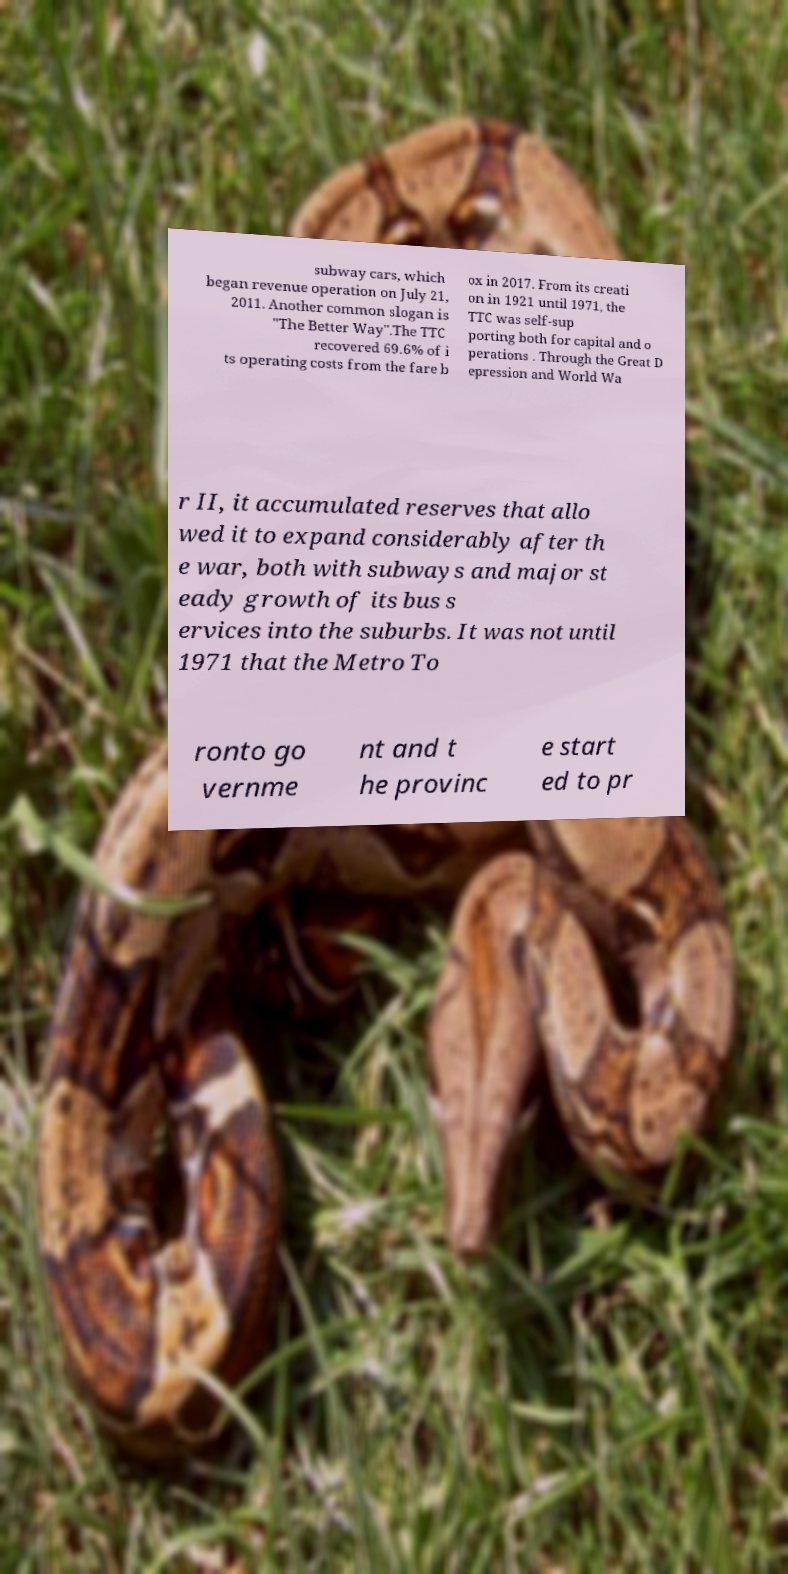Could you extract and type out the text from this image? subway cars, which began revenue operation on July 21, 2011. Another common slogan is "The Better Way".The TTC recovered 69.6% of i ts operating costs from the fare b ox in 2017. From its creati on in 1921 until 1971, the TTC was self-sup porting both for capital and o perations . Through the Great D epression and World Wa r II, it accumulated reserves that allo wed it to expand considerably after th e war, both with subways and major st eady growth of its bus s ervices into the suburbs. It was not until 1971 that the Metro To ronto go vernme nt and t he provinc e start ed to pr 